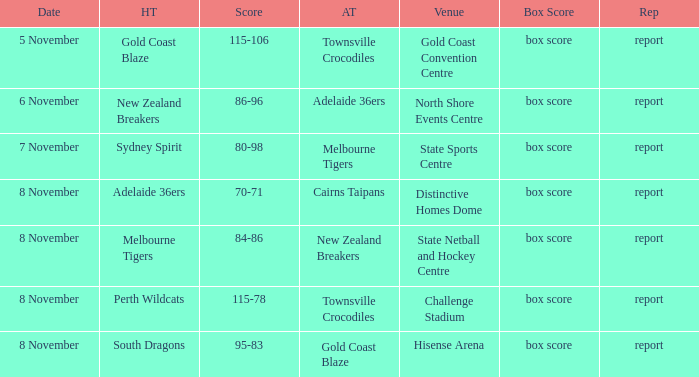Who was the home team at Gold Coast Convention Centre? Gold Coast Blaze. 